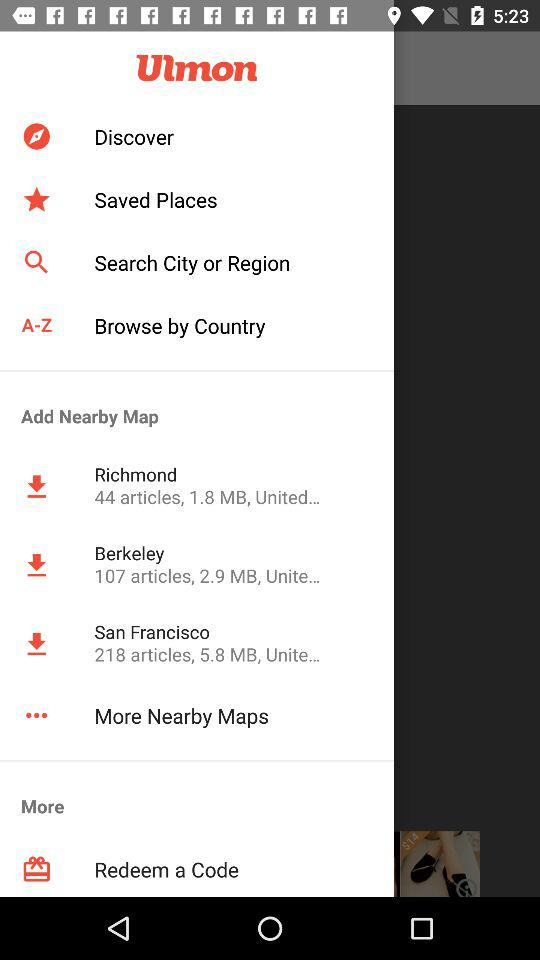What map has a size of 1.8 MB? The map that has a size of 1.8 MB is "Richmond". 